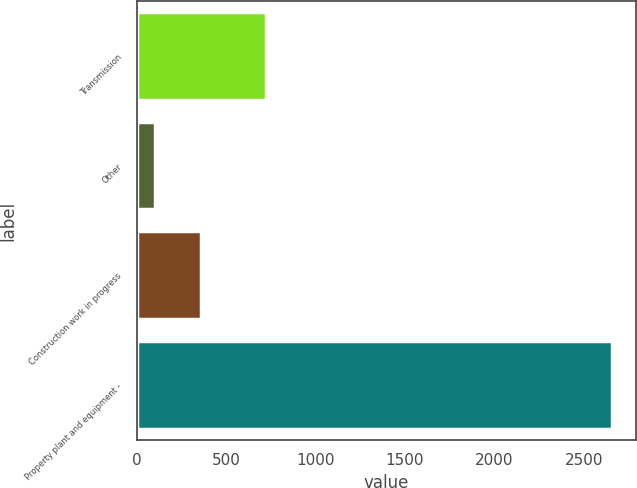<chart> <loc_0><loc_0><loc_500><loc_500><bar_chart><fcel>Transmission<fcel>Other<fcel>Construction work in progress<fcel>Property plant and equipment -<nl><fcel>723<fcel>104<fcel>359.3<fcel>2657<nl></chart> 